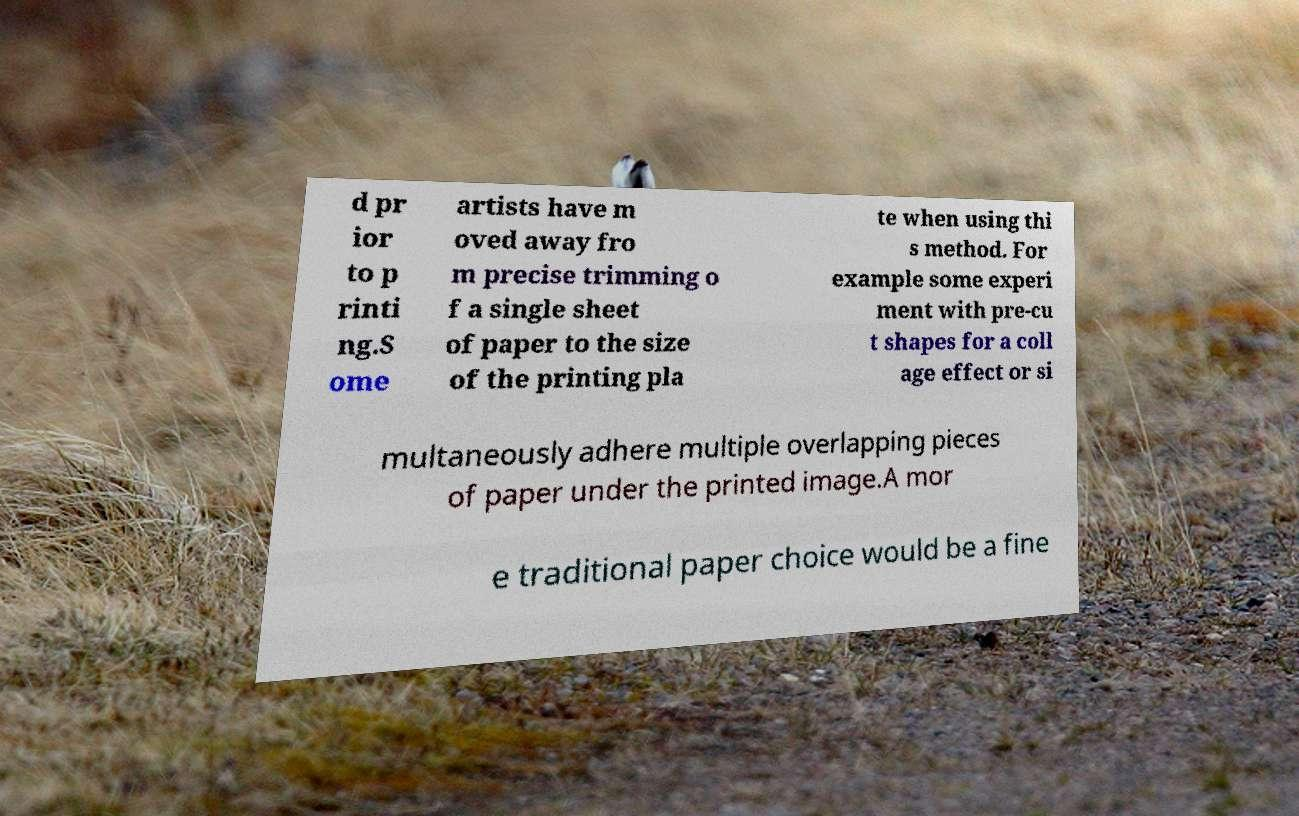For documentation purposes, I need the text within this image transcribed. Could you provide that? d pr ior to p rinti ng.S ome artists have m oved away fro m precise trimming o f a single sheet of paper to the size of the printing pla te when using thi s method. For example some experi ment with pre-cu t shapes for a coll age effect or si multaneously adhere multiple overlapping pieces of paper under the printed image.A mor e traditional paper choice would be a fine 